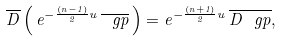<formula> <loc_0><loc_0><loc_500><loc_500>\overline { D } \left ( \, e ^ { - \frac { ( n - 1 ) } { 2 } u } \, \overline { \ g p } \, \right ) = e ^ { - \frac { ( n + 1 ) } { 2 } u } \, \overline { D \ g p } ,</formula> 